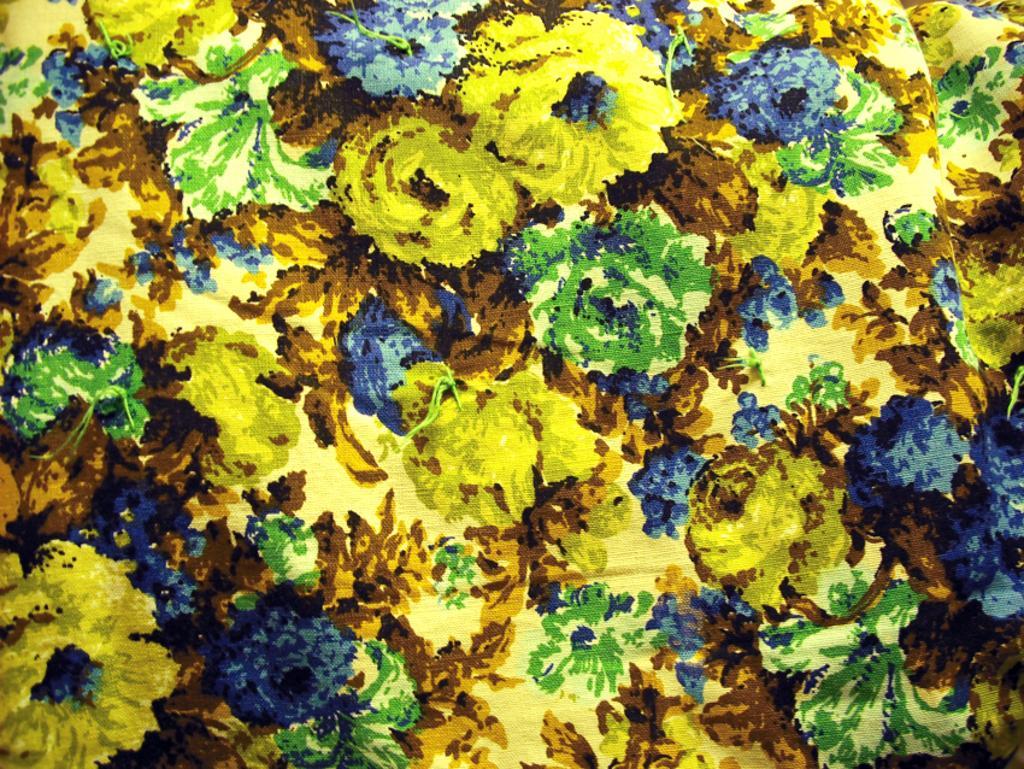Describe this image in one or two sentences. This is the picture of a painting with yellow and blue colored flowers, and leaves 